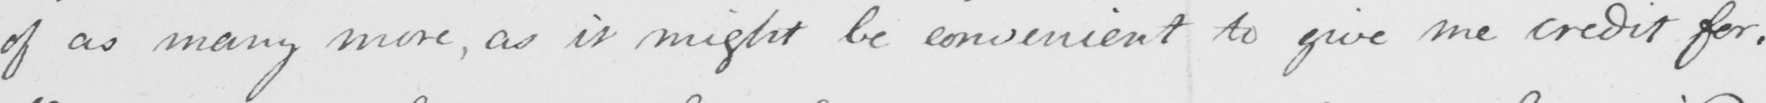What does this handwritten line say? of as many more , as it might be convenient to give me credit for . 